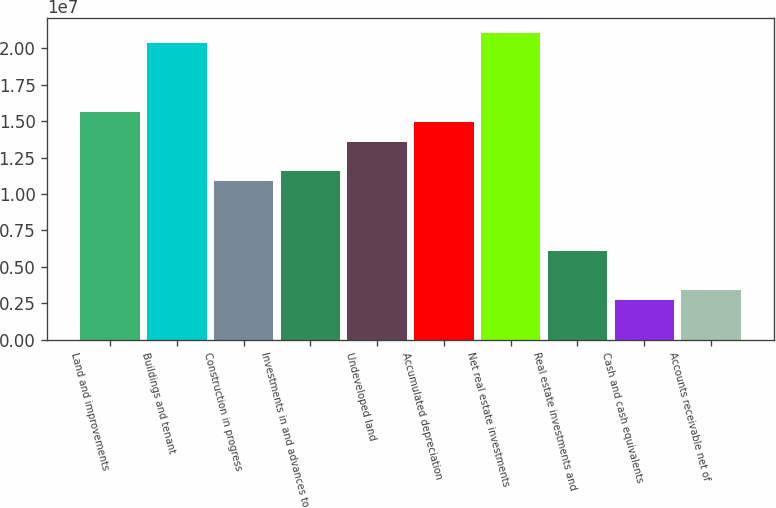Convert chart. <chart><loc_0><loc_0><loc_500><loc_500><bar_chart><fcel>Land and improvements<fcel>Buildings and tenant<fcel>Construction in progress<fcel>Investments in and advances to<fcel>Undeveloped land<fcel>Accumulated depreciation<fcel>Net real estate investments<fcel>Real estate investments and<fcel>Cash and cash equivalents<fcel>Accounts receivable net of<nl><fcel>1.56171e+07<fcel>2.03695e+07<fcel>1.08647e+07<fcel>1.15436e+07<fcel>1.35804e+07<fcel>1.49382e+07<fcel>2.10484e+07<fcel>6.11231e+06<fcel>2.71773e+06<fcel>3.39665e+06<nl></chart> 